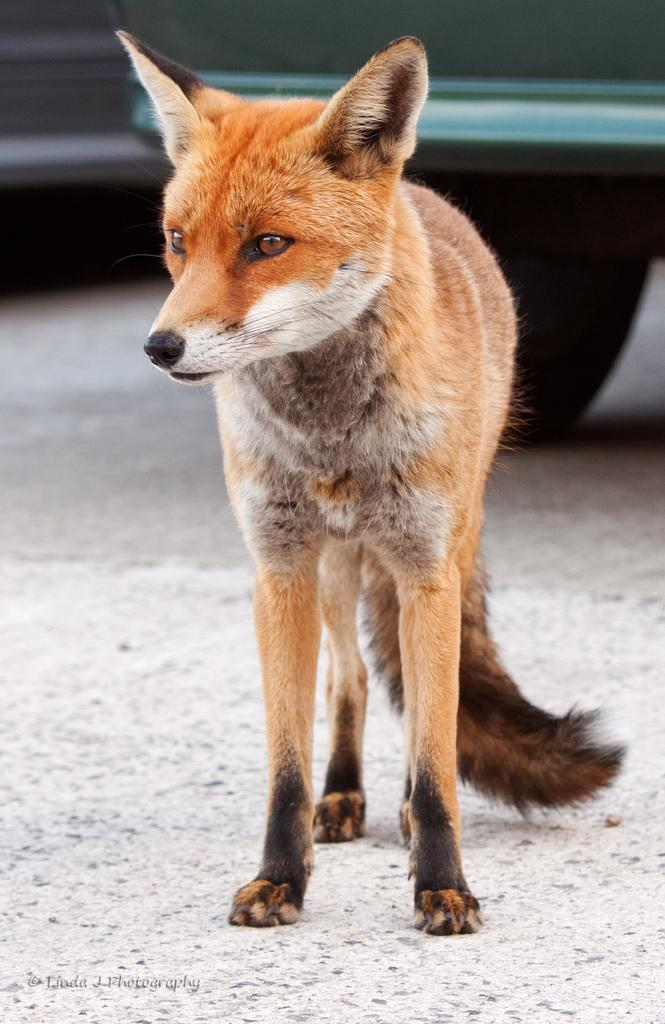What type of animal is in the image? There is a red fox in the image. What else can be seen in the image besides the fox? There is a road and a vehicle in the image. What type of comb is the fox using to read the vehicle's license plate in the image? There is no comb or reading of a license plate present in the image. The fox is not interacting with the vehicle in any way. 